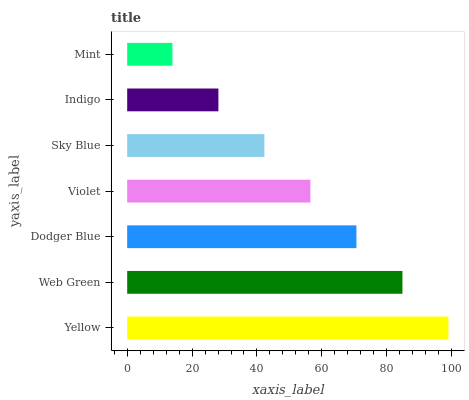Is Mint the minimum?
Answer yes or no. Yes. Is Yellow the maximum?
Answer yes or no. Yes. Is Web Green the minimum?
Answer yes or no. No. Is Web Green the maximum?
Answer yes or no. No. Is Yellow greater than Web Green?
Answer yes or no. Yes. Is Web Green less than Yellow?
Answer yes or no. Yes. Is Web Green greater than Yellow?
Answer yes or no. No. Is Yellow less than Web Green?
Answer yes or no. No. Is Violet the high median?
Answer yes or no. Yes. Is Violet the low median?
Answer yes or no. Yes. Is Dodger Blue the high median?
Answer yes or no. No. Is Web Green the low median?
Answer yes or no. No. 